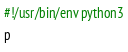<code> <loc_0><loc_0><loc_500><loc_500><_Python_>#!/usr/bin/env python3
p</code> 